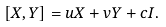Convert formula to latex. <formula><loc_0><loc_0><loc_500><loc_500>[ X , Y ] = u X + v Y + c I .</formula> 